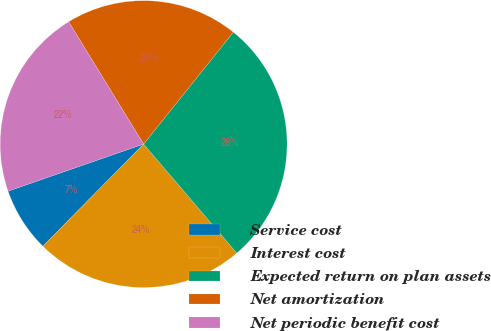<chart> <loc_0><loc_0><loc_500><loc_500><pie_chart><fcel>Service cost<fcel>Interest cost<fcel>Expected return on plan assets<fcel>Net amortization<fcel>Net periodic benefit cost<nl><fcel>7.29%<fcel>23.64%<fcel>27.99%<fcel>19.5%<fcel>21.57%<nl></chart> 